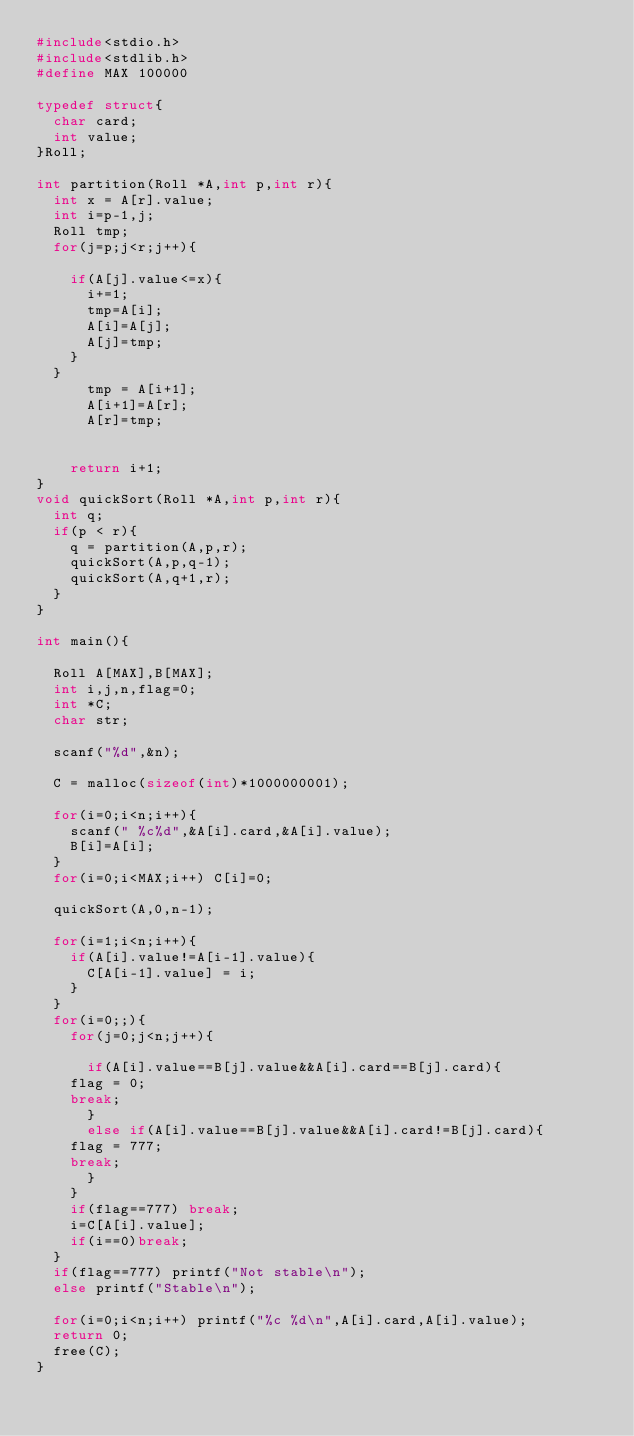Convert code to text. <code><loc_0><loc_0><loc_500><loc_500><_C_>#include<stdio.h>
#include<stdlib.h>
#define MAX 100000

typedef struct{
  char card;
  int value;
}Roll;

int partition(Roll *A,int p,int r){
  int x = A[r].value;
  int i=p-1,j;
  Roll tmp;
  for(j=p;j<r;j++){
    
    if(A[j].value<=x){
      i+=1;
      tmp=A[i];
      A[i]=A[j];
      A[j]=tmp;
    }
  }
      tmp = A[i+1];
      A[i+1]=A[r];
      A[r]=tmp;
  

    return i+1;
}
void quickSort(Roll *A,int p,int r){
  int q;
  if(p < r){
    q = partition(A,p,r);
    quickSort(A,p,q-1);
    quickSort(A,q+1,r);
  }
}

int main(){

  Roll A[MAX],B[MAX];
  int i,j,n,flag=0;
  int *C;
  char str;

  scanf("%d",&n);

  C = malloc(sizeof(int)*1000000001);
  
  for(i=0;i<n;i++){
    scanf(" %c%d",&A[i].card,&A[i].value);
    B[i]=A[i];  
  }
  for(i=0;i<MAX;i++) C[i]=0;
  
  quickSort(A,0,n-1);
  
  for(i=1;i<n;i++){
    if(A[i].value!=A[i-1].value){
      C[A[i-1].value] = i;
    }
  }
  for(i=0;;){
    for(j=0;j<n;j++){
      
      if(A[i].value==B[j].value&&A[i].card==B[j].card){
	flag = 0;
	break;
      }
      else if(A[i].value==B[j].value&&A[i].card!=B[j].card){
	flag = 777;
	break;
      }
    }
    if(flag==777) break;
    i=C[A[i].value];
    if(i==0)break;
  }
  if(flag==777) printf("Not stable\n");
  else printf("Stable\n");
  
  for(i=0;i<n;i++) printf("%c %d\n",A[i].card,A[i].value);
  return 0;
  free(C);
}</code> 